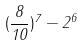Convert formula to latex. <formula><loc_0><loc_0><loc_500><loc_500>( \frac { 8 } { 1 0 } ) ^ { 7 } - 2 ^ { 6 }</formula> 